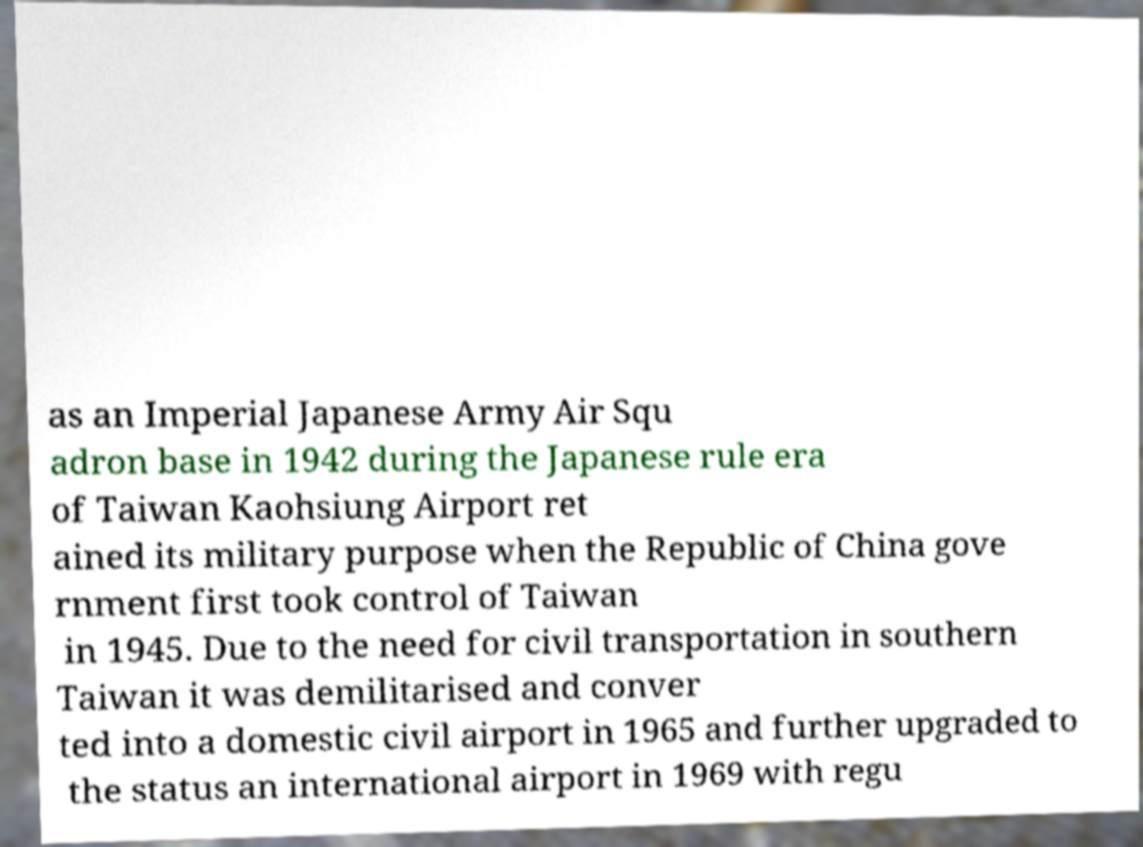Can you read and provide the text displayed in the image?This photo seems to have some interesting text. Can you extract and type it out for me? as an Imperial Japanese Army Air Squ adron base in 1942 during the Japanese rule era of Taiwan Kaohsiung Airport ret ained its military purpose when the Republic of China gove rnment first took control of Taiwan in 1945. Due to the need for civil transportation in southern Taiwan it was demilitarised and conver ted into a domestic civil airport in 1965 and further upgraded to the status an international airport in 1969 with regu 